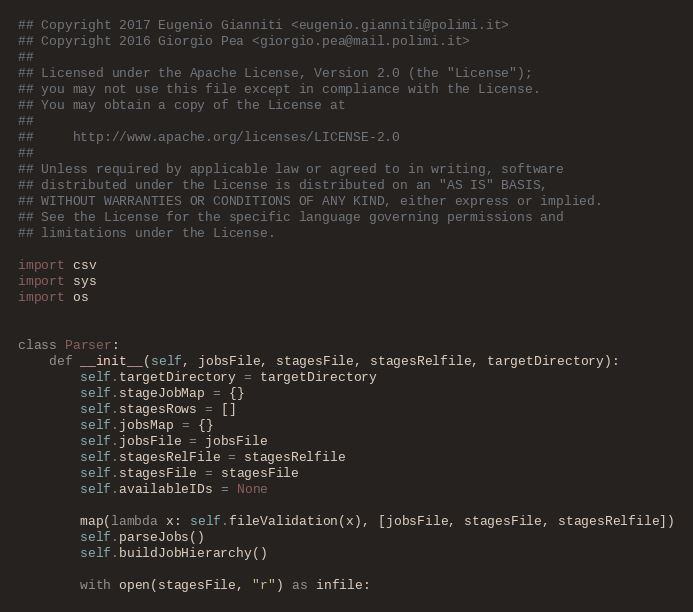<code> <loc_0><loc_0><loc_500><loc_500><_Python_>## Copyright 2017 Eugenio Gianniti <eugenio.gianniti@polimi.it>
## Copyright 2016 Giorgio Pea <giorgio.pea@mail.polimi.it>
##
## Licensed under the Apache License, Version 2.0 (the "License");
## you may not use this file except in compliance with the License.
## You may obtain a copy of the License at
##
##     http://www.apache.org/licenses/LICENSE-2.0
##
## Unless required by applicable law or agreed to in writing, software
## distributed under the License is distributed on an "AS IS" BASIS,
## WITHOUT WARRANTIES OR CONDITIONS OF ANY KIND, either express or implied.
## See the License for the specific language governing permissions and
## limitations under the License.

import csv
import sys
import os


class Parser:
    def __init__(self, jobsFile, stagesFile, stagesRelfile, targetDirectory):
        self.targetDirectory = targetDirectory
        self.stageJobMap = {}
        self.stagesRows = []
        self.jobsMap = {}
        self.jobsFile = jobsFile
        self.stagesRelFile = stagesRelfile
        self.stagesFile = stagesFile
        self.availableIDs = None

        map(lambda x: self.fileValidation(x), [jobsFile, stagesFile, stagesRelfile])
        self.parseJobs()
        self.buildJobHierarchy()

        with open(stagesFile, "r") as infile:</code> 